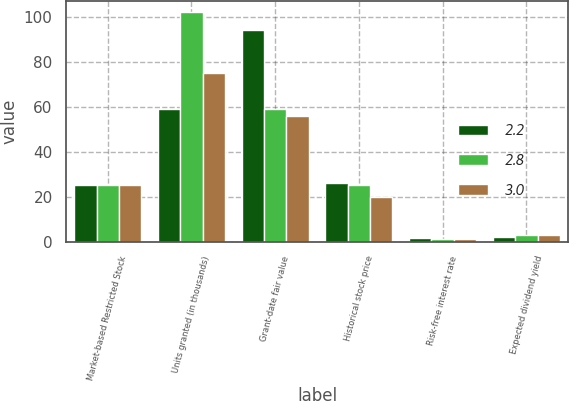Convert chart to OTSL. <chart><loc_0><loc_0><loc_500><loc_500><stacked_bar_chart><ecel><fcel>Market-based Restricted Stock<fcel>Units granted (in thousands)<fcel>Grant-date fair value<fcel>Historical stock price<fcel>Risk-free interest rate<fcel>Expected dividend yield<nl><fcel>2.2<fcel>25.1<fcel>59<fcel>94.25<fcel>26<fcel>1.6<fcel>2.2<nl><fcel>2.8<fcel>25.1<fcel>102<fcel>58.95<fcel>25.1<fcel>1.1<fcel>3<nl><fcel>3<fcel>25.1<fcel>75<fcel>55.67<fcel>20<fcel>1.1<fcel>2.8<nl></chart> 